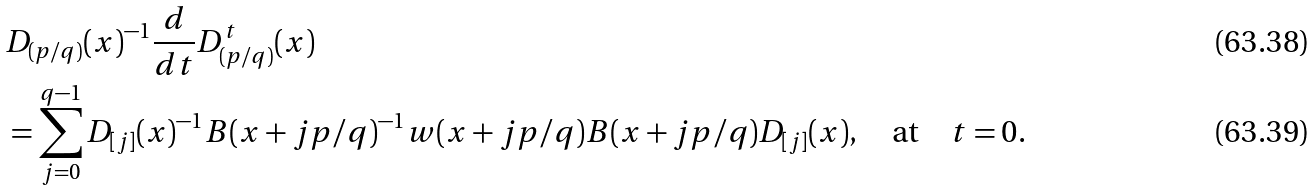Convert formula to latex. <formula><loc_0><loc_0><loc_500><loc_500>& D _ { ( p / q ) } ( x ) ^ { - 1 } \frac { d } { d t } D ^ { t } _ { ( p / q ) } ( x ) \\ & = \sum _ { j = 0 } ^ { q - 1 } D _ { [ j ] } ( x ) ^ { - 1 } B ( x + j p / q ) ^ { - 1 } w ( x + j p / q ) B ( x + j p / q ) D _ { [ j ] } ( x ) , \quad \text {at} \quad t = 0 .</formula> 